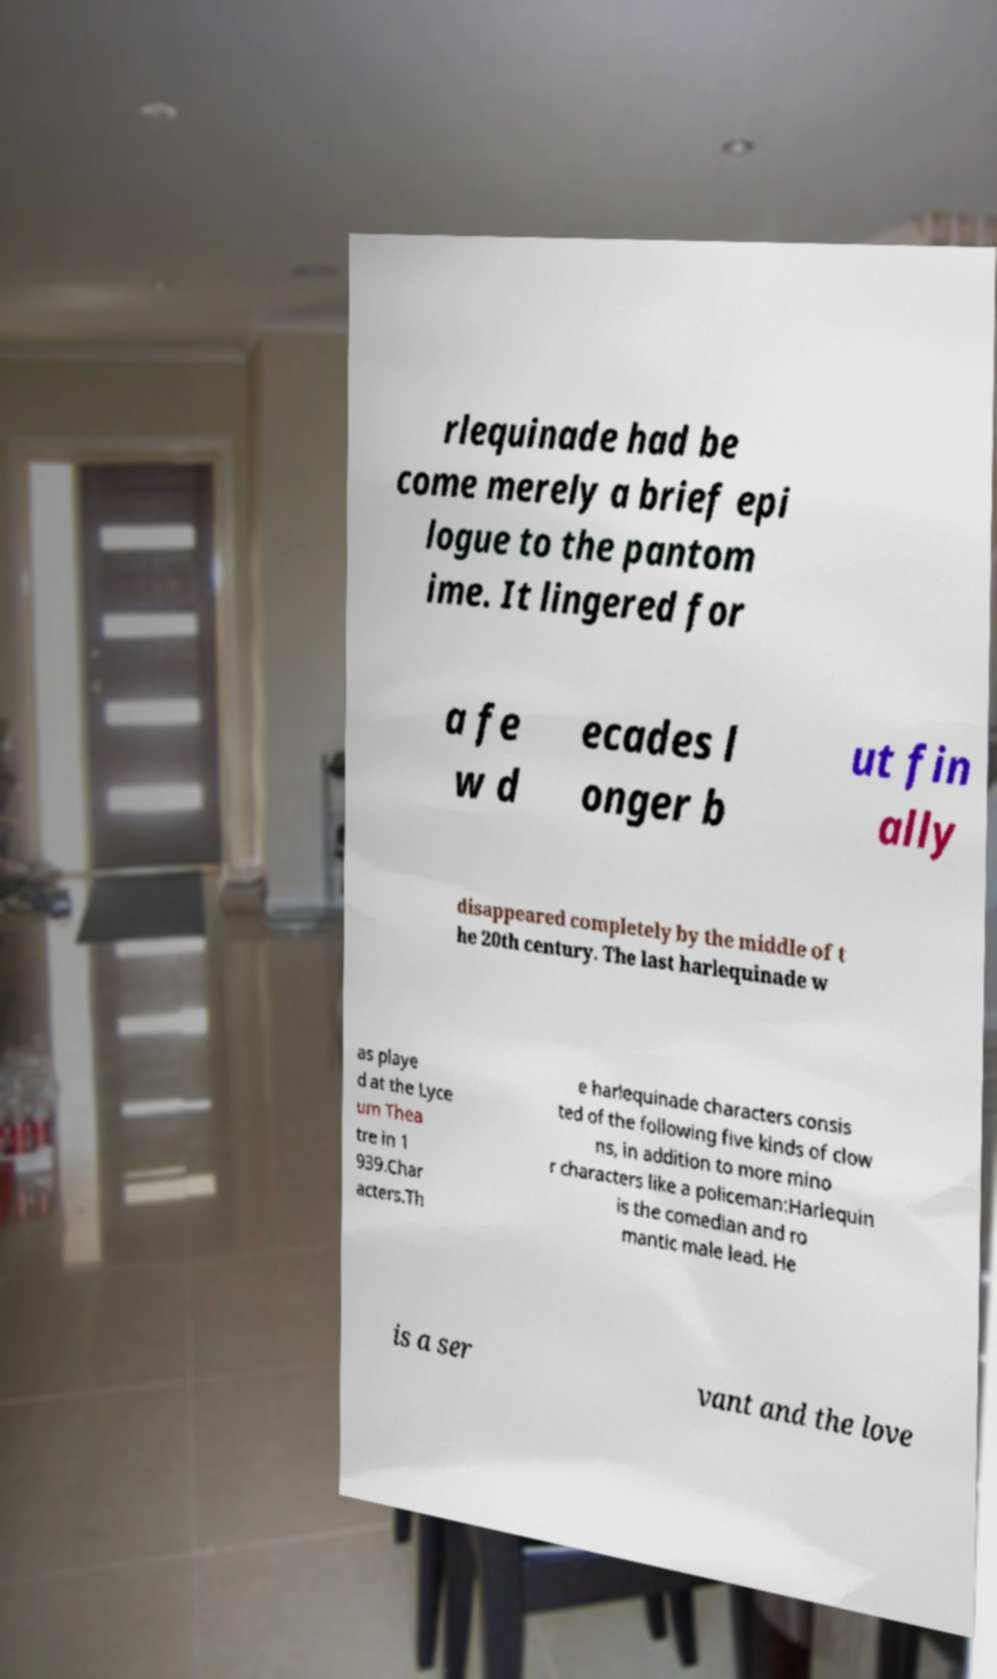Could you extract and type out the text from this image? rlequinade had be come merely a brief epi logue to the pantom ime. It lingered for a fe w d ecades l onger b ut fin ally disappeared completely by the middle of t he 20th century. The last harlequinade w as playe d at the Lyce um Thea tre in 1 939.Char acters.Th e harlequinade characters consis ted of the following five kinds of clow ns, in addition to more mino r characters like a policeman:Harlequin is the comedian and ro mantic male lead. He is a ser vant and the love 